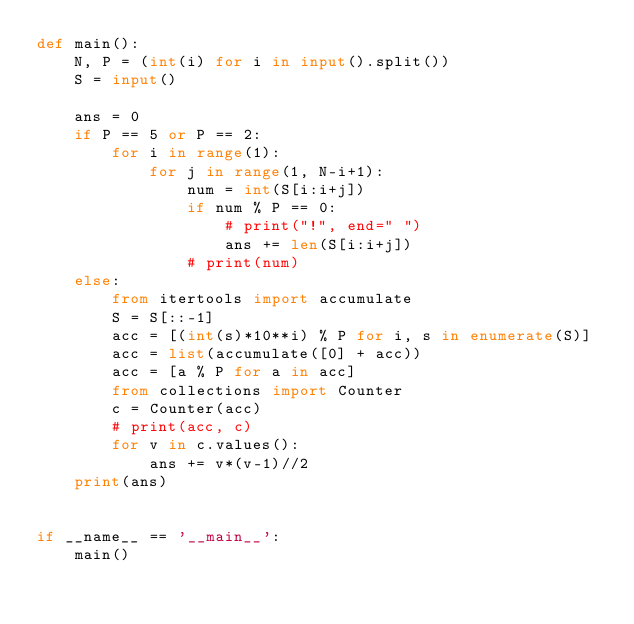Convert code to text. <code><loc_0><loc_0><loc_500><loc_500><_Python_>def main():
    N, P = (int(i) for i in input().split())
    S = input()

    ans = 0
    if P == 5 or P == 2:
        for i in range(1):
            for j in range(1, N-i+1):
                num = int(S[i:i+j])
                if num % P == 0:
                    # print("!", end=" ")
                    ans += len(S[i:i+j])
                # print(num)
    else:
        from itertools import accumulate
        S = S[::-1]
        acc = [(int(s)*10**i) % P for i, s in enumerate(S)]
        acc = list(accumulate([0] + acc))
        acc = [a % P for a in acc]
        from collections import Counter
        c = Counter(acc)
        # print(acc, c)
        for v in c.values():
            ans += v*(v-1)//2
    print(ans)


if __name__ == '__main__':
    main()
</code> 